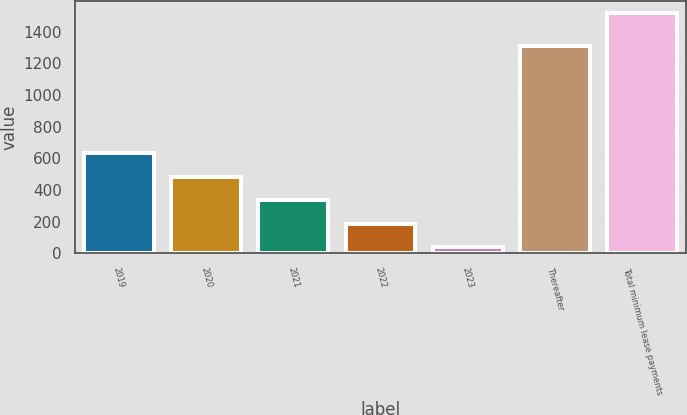Convert chart. <chart><loc_0><loc_0><loc_500><loc_500><bar_chart><fcel>2019<fcel>2020<fcel>2021<fcel>2022<fcel>2023<fcel>Thereafter<fcel>Total minimum lease payments<nl><fcel>629.8<fcel>481.6<fcel>333.4<fcel>185.2<fcel>37<fcel>1309<fcel>1519<nl></chart> 